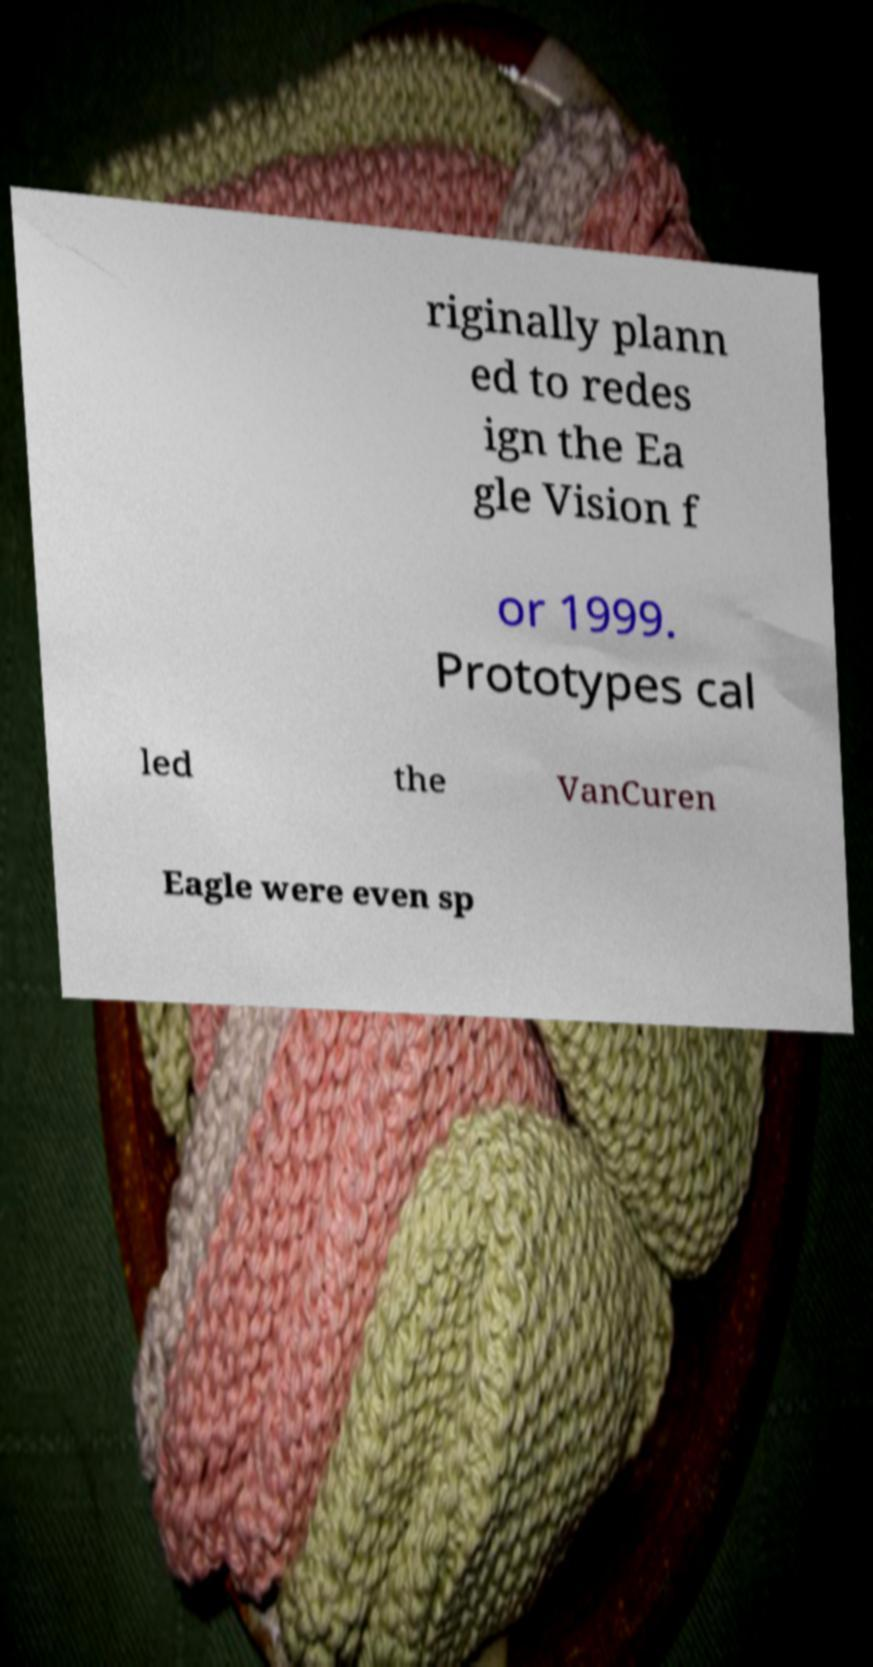Please identify and transcribe the text found in this image. riginally plann ed to redes ign the Ea gle Vision f or 1999. Prototypes cal led the VanCuren Eagle were even sp 